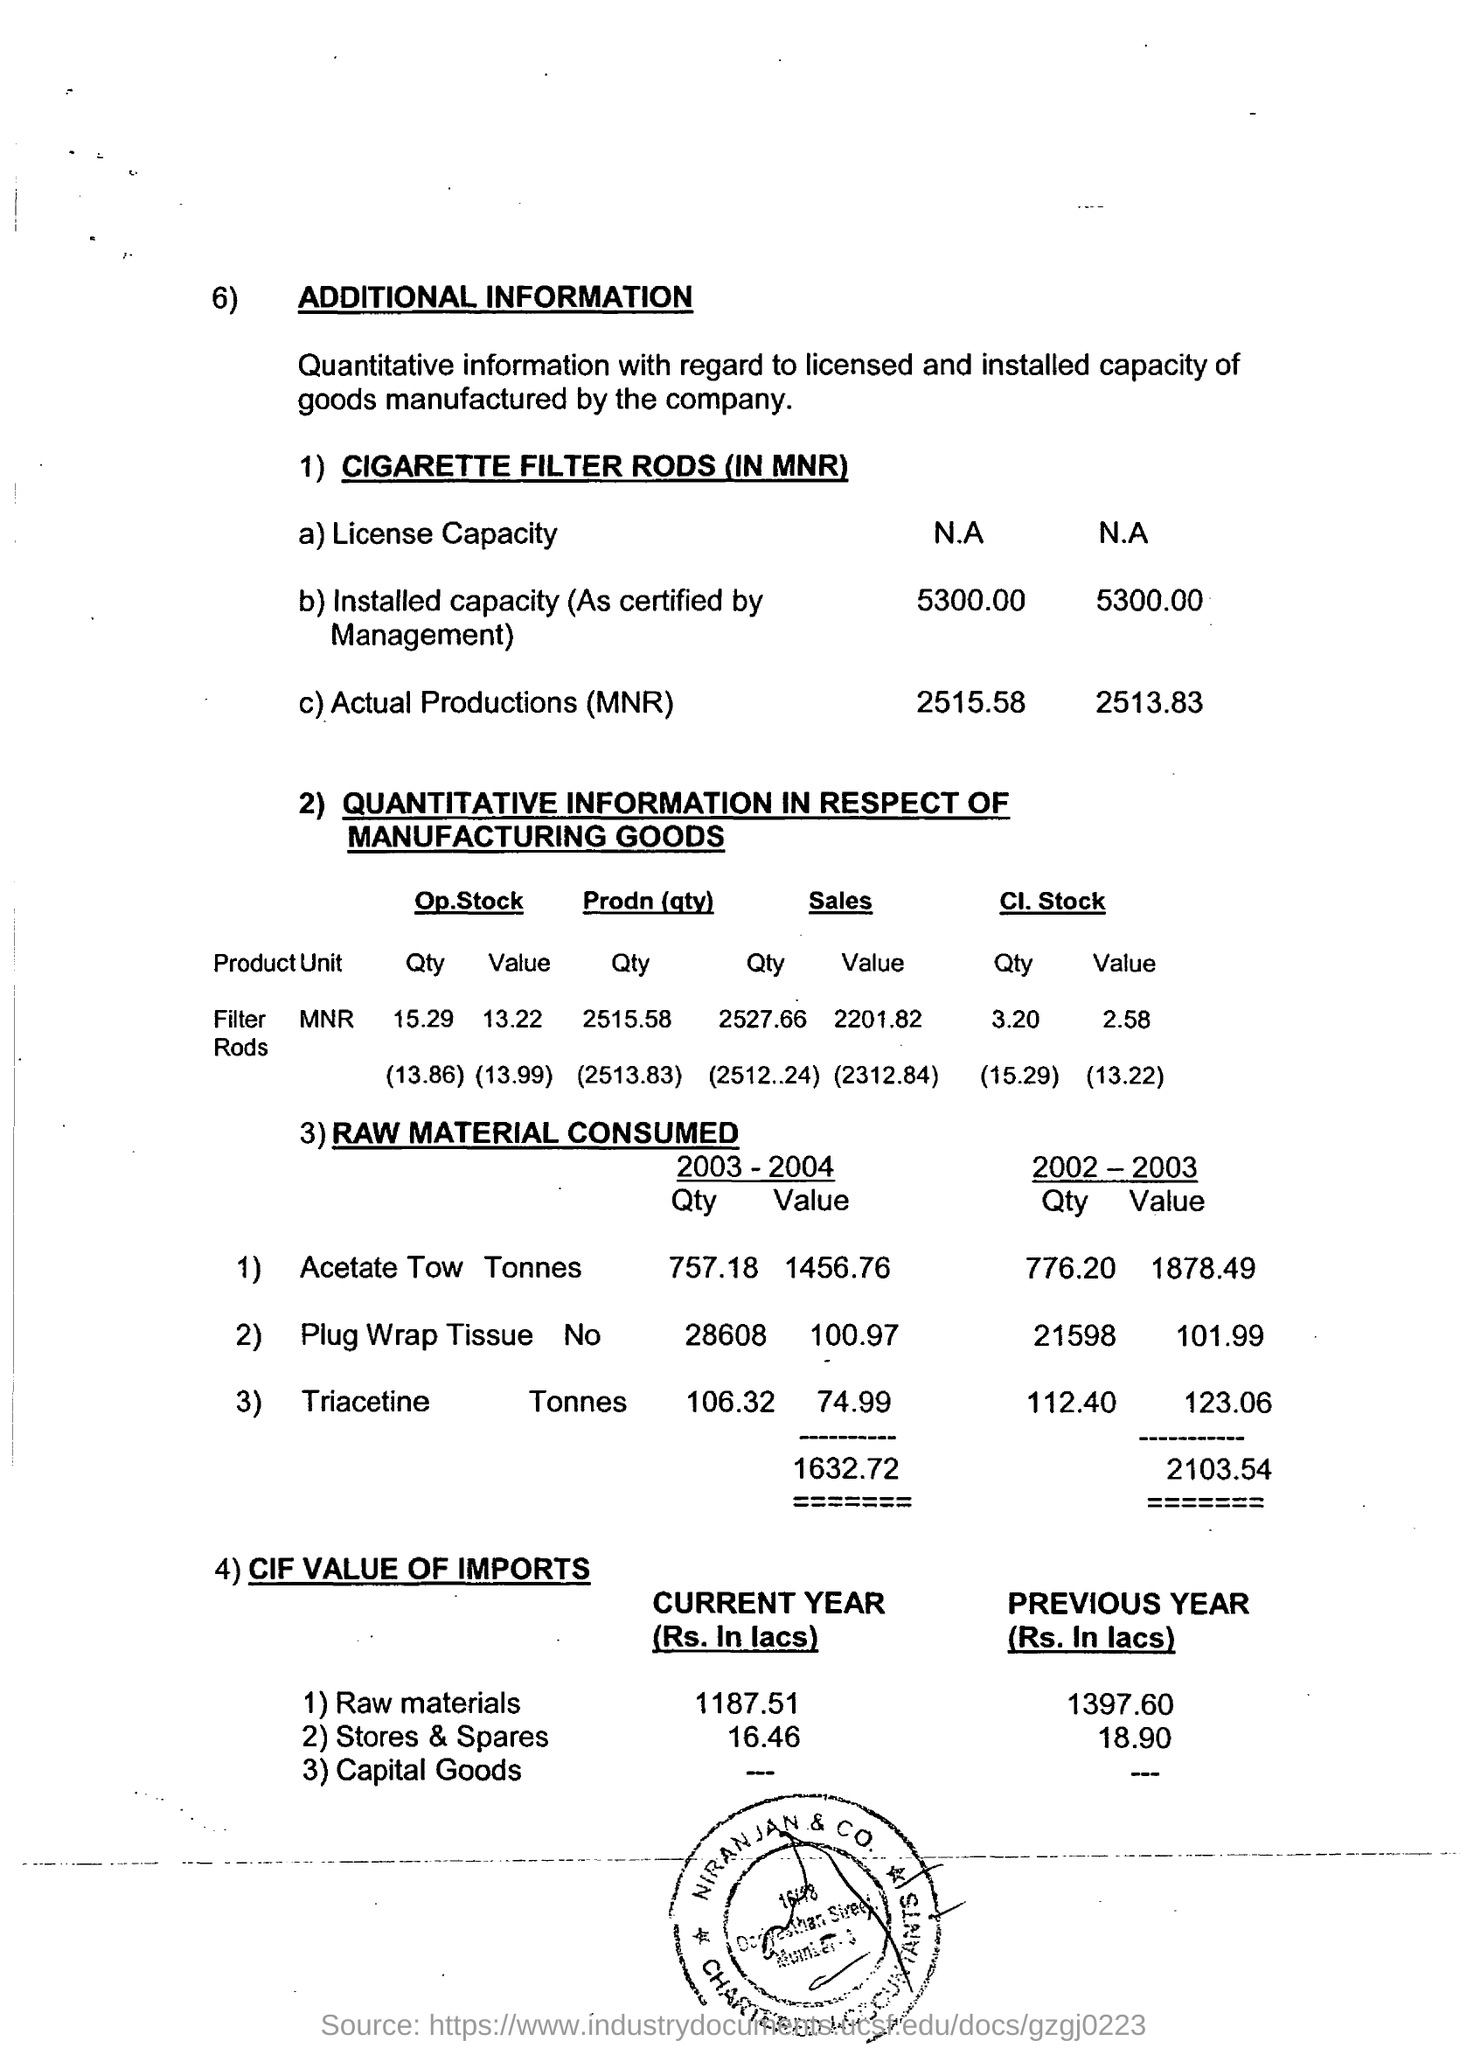Identify some key points in this picture. In 2004, the amount of triacetine consumed was 74.99... The value of imports for raw materials in the current year is 1187.51. In 2004, the total value of raw materials consumed was 1632.72. 